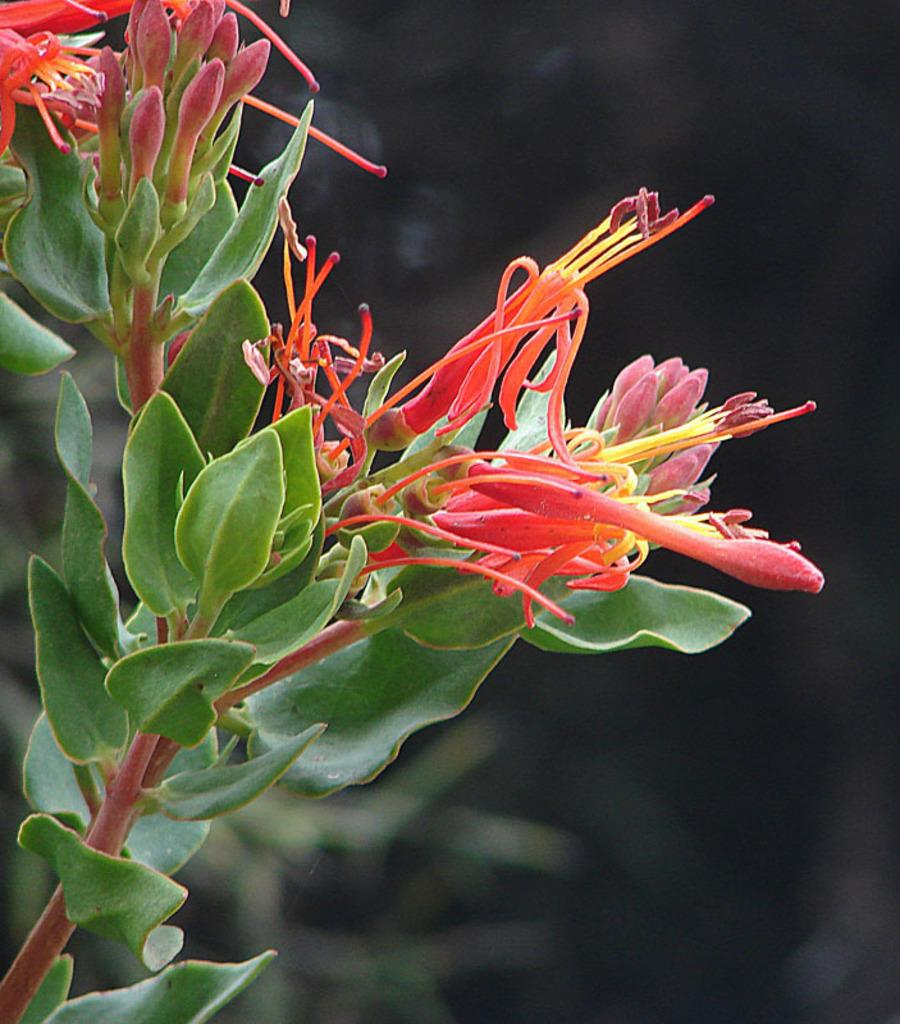What type of plant life is visible in the image? There are flowers, flower buds, leaves, and stems visible in the image. Can you describe the different stages of the flowers in the image? Yes, there are both fully bloomed flowers and flower buds in the image. What parts of the plants are visible in the image? In addition to the flowers and flower buds, there are leaves and stems visible in the image. How is the background of the image depicted? The background of the image has a blurred view. What type of harmony can be heard in the background of the image? There is no audible harmony present in the image, as it is a still image of plant life. 